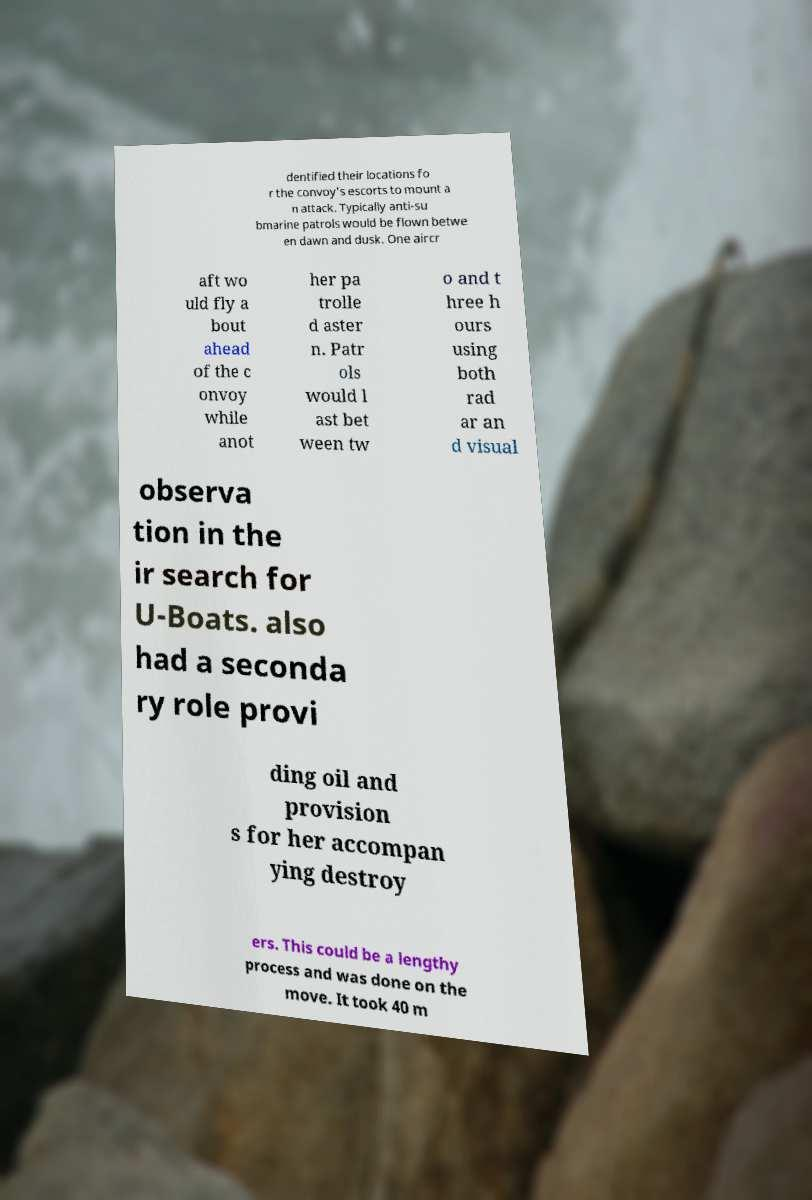There's text embedded in this image that I need extracted. Can you transcribe it verbatim? dentified their locations fo r the convoy's escorts to mount a n attack. Typically anti-su bmarine patrols would be flown betwe en dawn and dusk. One aircr aft wo uld fly a bout ahead of the c onvoy while anot her pa trolle d aster n. Patr ols would l ast bet ween tw o and t hree h ours using both rad ar an d visual observa tion in the ir search for U-Boats. also had a seconda ry role provi ding oil and provision s for her accompan ying destroy ers. This could be a lengthy process and was done on the move. It took 40 m 